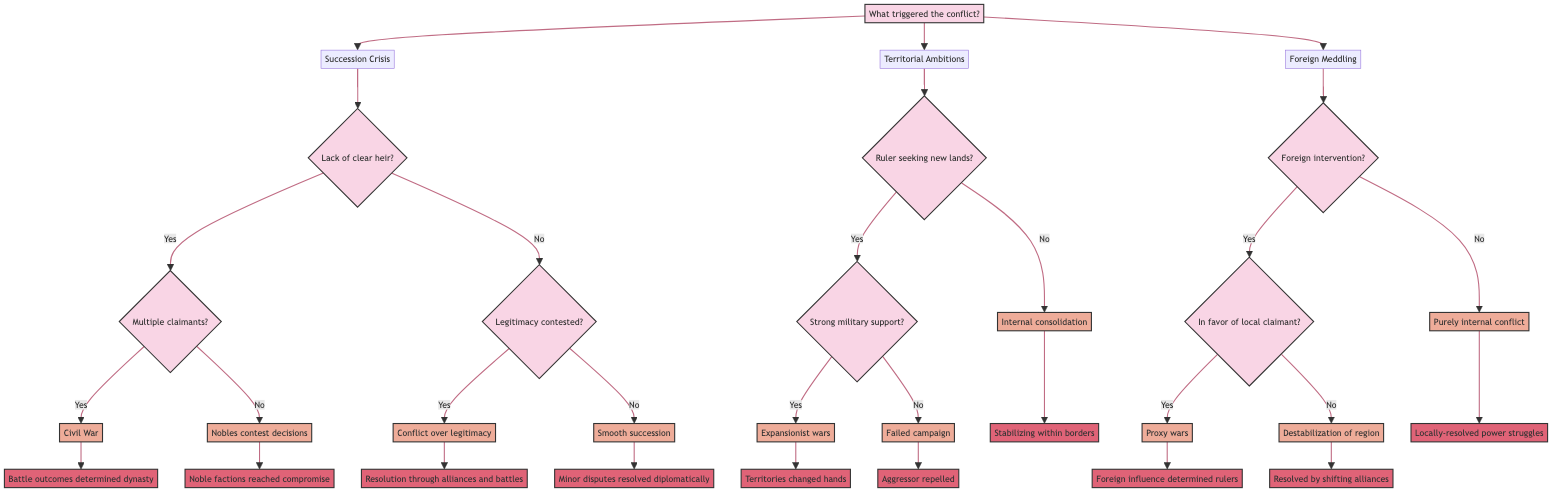What are the three main triggers of conflict in the diagram? The diagram categorizes the triggers of conflict into three main branches: Succession Crisis, Territorial Ambitions, and Foreign Meddling.
Answer: Succession Crisis, Territorial Ambitions, Foreign Meddling How many nodes are there under the Succession Crisis branch? Under the Succession Crisis branch, there are five nodes: the main question node and four outcome nodes (Civil War, Nobles contest decisions, Conflict over legitimacy, Smooth succession).
Answer: 5 What effect follows if there is a lack of a clear heir and multiple claimants emerge? If there is a lack of a clear heir and multiple claimants emerge, the effect is Civil War, as indicated in the diagram.
Answer: Civil War What resolution occurs when nobles contest royal decisions? The diagram states that when nobles contest royal decisions, the resolution is that noble factions eventually reached a compromise.
Answer: Noble factions reached compromise If a ruler seeks new lands without strong military support, what is the outcome? The outcome when a ruler seeks new lands without strong military support is a Failed campaign, as shown in the diagram.
Answer: Failed campaign What type of conflict results when foreign powers intervene but do not support a local claimant? The diagram indicates that when foreign powers intervene but do not support a local claimant, the result is Destabilization of the region.
Answer: Destabilization of the region Which question node leads to the resolution of territories changing hands? The question node that leads to the resolution of territories changing hands is "Did the attacking ruler have strong military support?" followed by a "Yes" answer.
Answer: Did the attacking ruler have strong military support? What effect results from purely internal conflict according to the diagram? According to the diagram, purely internal conflict results in Locally-resolved power struggles.
Answer: Locally-resolved power struggles What leads to minor disputes being resolved diplomatically? The resolution of minor disputes diplomatically occurs when there is a Smooth succession, which is indicated in the diagram.
Answer: Smooth succession 